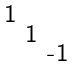Convert formula to latex. <formula><loc_0><loc_0><loc_500><loc_500>\begin{smallmatrix} 1 \\ & 1 \\ & & \text {-} 1 \end{smallmatrix}</formula> 